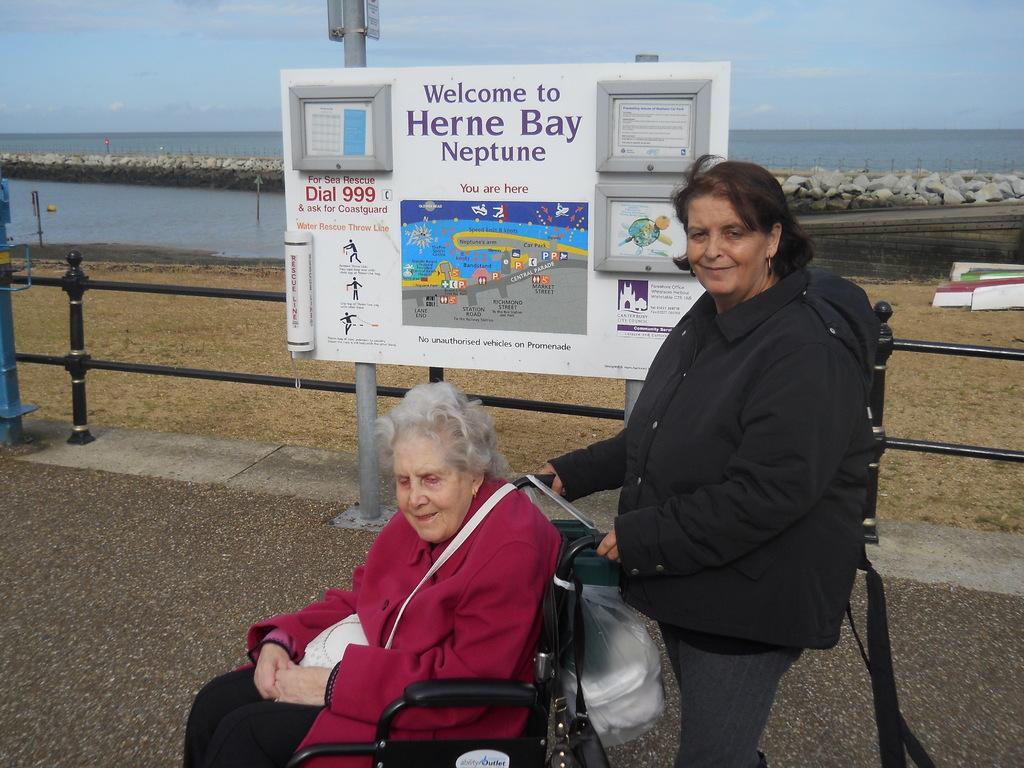Can you describe this image briefly? In this picture, we see the old woman in the red jacket is sitting on the wheelchair. Behind that, we see the woman in black jacket is standing and she is smiling. Behind her, we see a board in white color with some text written on it. Behind that, we see a pole and a railing. In the background, we see stones and water. This water might be in the river. At the bottom, we see the road and at the top, we see the sky. 